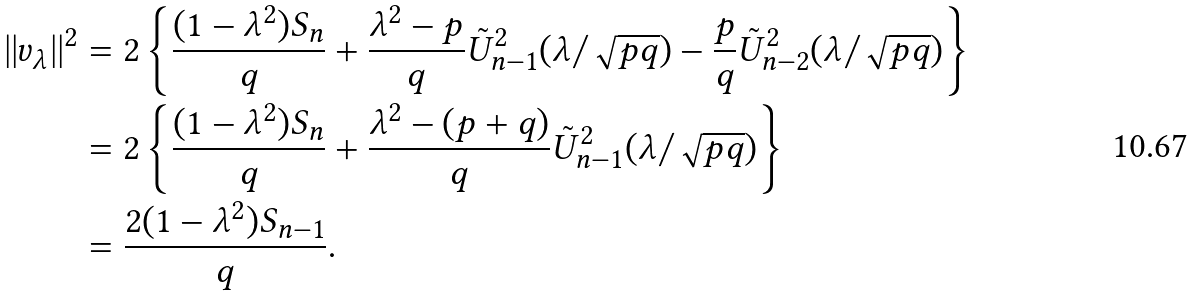Convert formula to latex. <formula><loc_0><loc_0><loc_500><loc_500>| | v _ { \lambda } | | ^ { 2 } & = 2 \left \{ \frac { ( 1 - \lambda ^ { 2 } ) S _ { n } } { q } + \frac { \lambda ^ { 2 } - p } { q } \tilde { U } _ { n - 1 } ^ { 2 } ( \lambda / \sqrt { p q } ) - \frac { p } { q } \tilde { U } _ { n - 2 } ^ { 2 } ( \lambda / \sqrt { p q } ) \right \} \\ & = 2 \left \{ \frac { ( 1 - \lambda ^ { 2 } ) S _ { n } } { q } + \frac { \lambda ^ { 2 } - ( p + q ) } { q } \tilde { U } _ { n - 1 } ^ { 2 } ( \lambda / \sqrt { p q } ) \right \} \\ & = \frac { 2 ( 1 - \lambda ^ { 2 } ) S _ { n - 1 } } { q } .</formula> 